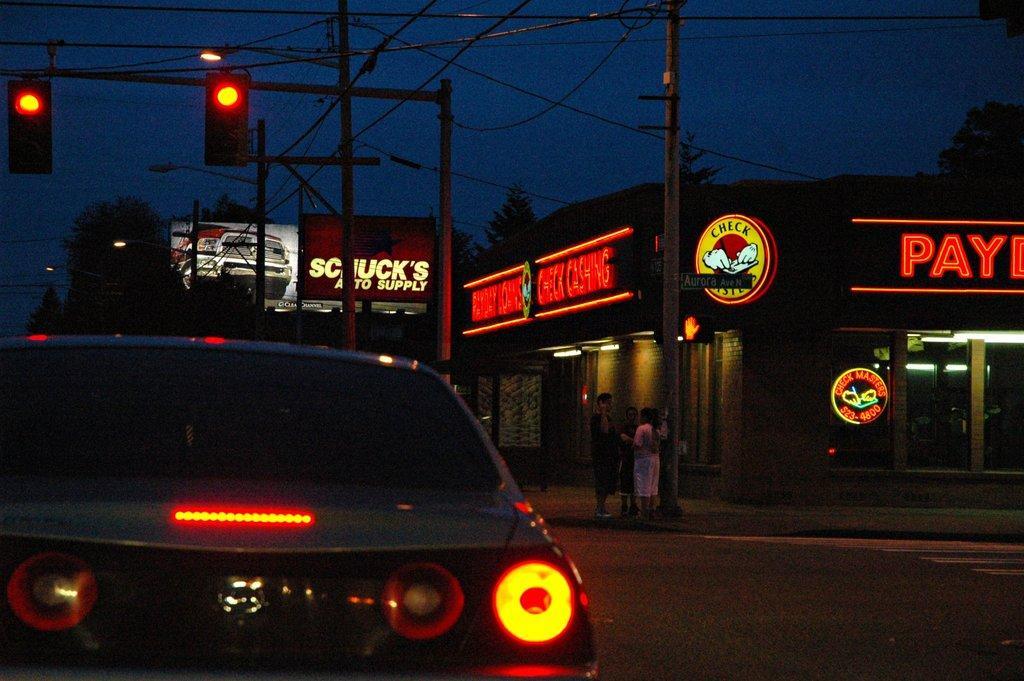How would you summarize this image in a sentence or two? This image is taken outdoors. On the left side of the image a car is moving on the road. On the right side of the image there is a road and there is a room with walls and doors and there are many boards with text on them. In the middle of the image there are a few poles with street lights, signal lights and wires. In the background there are a few trees. At the top of the image there is a sky. 